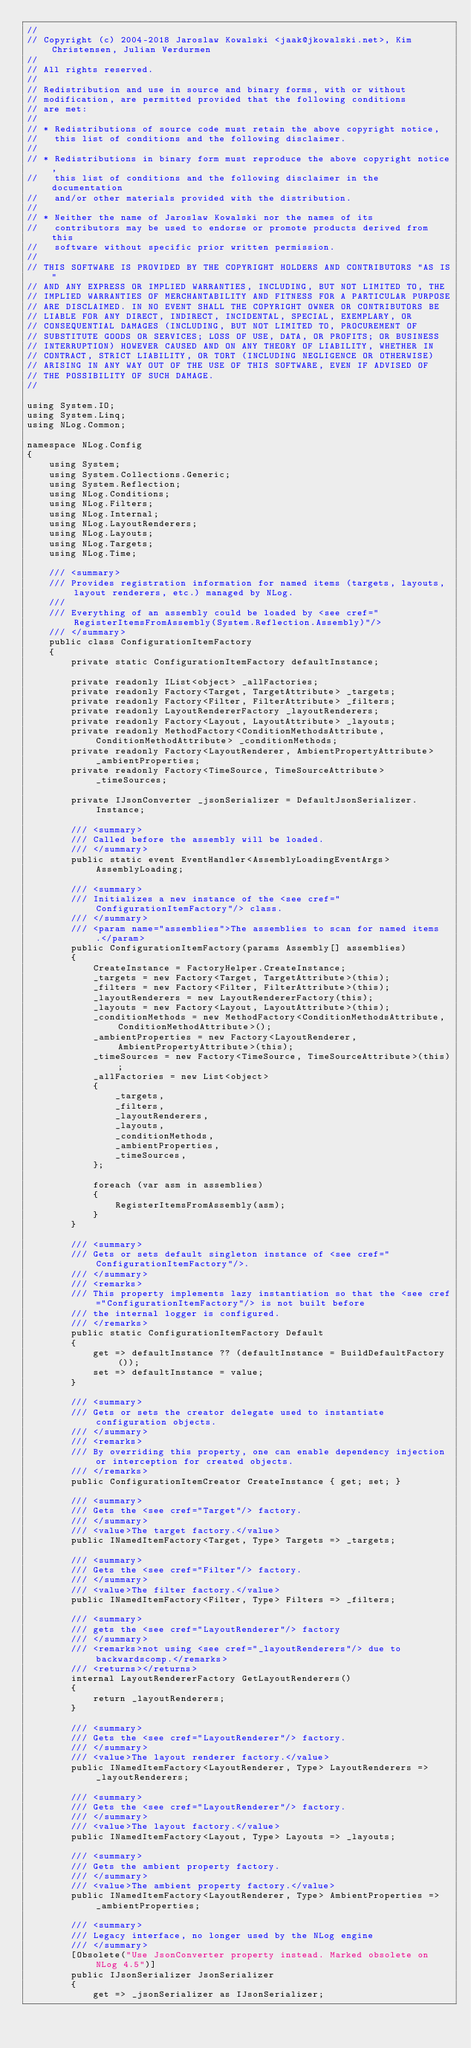Convert code to text. <code><loc_0><loc_0><loc_500><loc_500><_C#_>// 
// Copyright (c) 2004-2018 Jaroslaw Kowalski <jaak@jkowalski.net>, Kim Christensen, Julian Verdurmen
// 
// All rights reserved.
// 
// Redistribution and use in source and binary forms, with or without 
// modification, are permitted provided that the following conditions 
// are met:
// 
// * Redistributions of source code must retain the above copyright notice, 
//   this list of conditions and the following disclaimer. 
// 
// * Redistributions in binary form must reproduce the above copyright notice,
//   this list of conditions and the following disclaimer in the documentation
//   and/or other materials provided with the distribution. 
// 
// * Neither the name of Jaroslaw Kowalski nor the names of its 
//   contributors may be used to endorse or promote products derived from this
//   software without specific prior written permission. 
// 
// THIS SOFTWARE IS PROVIDED BY THE COPYRIGHT HOLDERS AND CONTRIBUTORS "AS IS"
// AND ANY EXPRESS OR IMPLIED WARRANTIES, INCLUDING, BUT NOT LIMITED TO, THE 
// IMPLIED WARRANTIES OF MERCHANTABILITY AND FITNESS FOR A PARTICULAR PURPOSE 
// ARE DISCLAIMED. IN NO EVENT SHALL THE COPYRIGHT OWNER OR CONTRIBUTORS BE 
// LIABLE FOR ANY DIRECT, INDIRECT, INCIDENTAL, SPECIAL, EXEMPLARY, OR 
// CONSEQUENTIAL DAMAGES (INCLUDING, BUT NOT LIMITED TO, PROCUREMENT OF
// SUBSTITUTE GOODS OR SERVICES; LOSS OF USE, DATA, OR PROFITS; OR BUSINESS 
// INTERRUPTION) HOWEVER CAUSED AND ON ANY THEORY OF LIABILITY, WHETHER IN 
// CONTRACT, STRICT LIABILITY, OR TORT (INCLUDING NEGLIGENCE OR OTHERWISE) 
// ARISING IN ANY WAY OUT OF THE USE OF THIS SOFTWARE, EVEN IF ADVISED OF 
// THE POSSIBILITY OF SUCH DAMAGE.
// 

using System.IO;
using System.Linq;
using NLog.Common;

namespace NLog.Config
{
    using System;
    using System.Collections.Generic;
    using System.Reflection;
    using NLog.Conditions;
    using NLog.Filters;
    using NLog.Internal;
    using NLog.LayoutRenderers;
    using NLog.Layouts;
    using NLog.Targets;
    using NLog.Time;

    /// <summary>
    /// Provides registration information for named items (targets, layouts, layout renderers, etc.) managed by NLog.
    /// 
    /// Everything of an assembly could be loaded by <see cref="RegisterItemsFromAssembly(System.Reflection.Assembly)"/>
    /// </summary>
    public class ConfigurationItemFactory
    {
        private static ConfigurationItemFactory defaultInstance;

        private readonly IList<object> _allFactories;
        private readonly Factory<Target, TargetAttribute> _targets;
        private readonly Factory<Filter, FilterAttribute> _filters;
        private readonly LayoutRendererFactory _layoutRenderers;
        private readonly Factory<Layout, LayoutAttribute> _layouts;
        private readonly MethodFactory<ConditionMethodsAttribute, ConditionMethodAttribute> _conditionMethods;
        private readonly Factory<LayoutRenderer, AmbientPropertyAttribute> _ambientProperties;
        private readonly Factory<TimeSource, TimeSourceAttribute> _timeSources;

        private IJsonConverter _jsonSerializer = DefaultJsonSerializer.Instance;

        /// <summary>
        /// Called before the assembly will be loaded.
        /// </summary>
        public static event EventHandler<AssemblyLoadingEventArgs> AssemblyLoading;

        /// <summary>
        /// Initializes a new instance of the <see cref="ConfigurationItemFactory"/> class.
        /// </summary>
        /// <param name="assemblies">The assemblies to scan for named items.</param>
        public ConfigurationItemFactory(params Assembly[] assemblies)
        {
            CreateInstance = FactoryHelper.CreateInstance;
            _targets = new Factory<Target, TargetAttribute>(this);
            _filters = new Factory<Filter, FilterAttribute>(this);
            _layoutRenderers = new LayoutRendererFactory(this);
            _layouts = new Factory<Layout, LayoutAttribute>(this);
            _conditionMethods = new MethodFactory<ConditionMethodsAttribute, ConditionMethodAttribute>();
            _ambientProperties = new Factory<LayoutRenderer, AmbientPropertyAttribute>(this);
            _timeSources = new Factory<TimeSource, TimeSourceAttribute>(this);
            _allFactories = new List<object>
            {
                _targets,
                _filters,
                _layoutRenderers,
                _layouts,
                _conditionMethods,
                _ambientProperties,
                _timeSources,
            };

            foreach (var asm in assemblies)
            {
                RegisterItemsFromAssembly(asm);
            }
        }

        /// <summary>
        /// Gets or sets default singleton instance of <see cref="ConfigurationItemFactory"/>.
        /// </summary>
        /// <remarks>
        /// This property implements lazy instantiation so that the <see cref="ConfigurationItemFactory"/> is not built before 
        /// the internal logger is configured.
        /// </remarks>
        public static ConfigurationItemFactory Default
        {
            get => defaultInstance ?? (defaultInstance = BuildDefaultFactory());
            set => defaultInstance = value;
        }

        /// <summary>
        /// Gets or sets the creator delegate used to instantiate configuration objects.
        /// </summary>
        /// <remarks>
        /// By overriding this property, one can enable dependency injection or interception for created objects.
        /// </remarks>
        public ConfigurationItemCreator CreateInstance { get; set; }

        /// <summary>
        /// Gets the <see cref="Target"/> factory.
        /// </summary>
        /// <value>The target factory.</value>
        public INamedItemFactory<Target, Type> Targets => _targets;

        /// <summary>
        /// Gets the <see cref="Filter"/> factory.
        /// </summary>
        /// <value>The filter factory.</value>
        public INamedItemFactory<Filter, Type> Filters => _filters;

        /// <summary>
        /// gets the <see cref="LayoutRenderer"/> factory
        /// </summary>
        /// <remarks>not using <see cref="_layoutRenderers"/> due to backwardscomp.</remarks>
        /// <returns></returns>
        internal LayoutRendererFactory GetLayoutRenderers()
        {
            return _layoutRenderers;
        }

        /// <summary>
        /// Gets the <see cref="LayoutRenderer"/> factory.
        /// </summary>
        /// <value>The layout renderer factory.</value>
        public INamedItemFactory<LayoutRenderer, Type> LayoutRenderers => _layoutRenderers;

        /// <summary>
        /// Gets the <see cref="LayoutRenderer"/> factory.
        /// </summary>
        /// <value>The layout factory.</value>
        public INamedItemFactory<Layout, Type> Layouts => _layouts;

        /// <summary>
        /// Gets the ambient property factory.
        /// </summary>
        /// <value>The ambient property factory.</value>
        public INamedItemFactory<LayoutRenderer, Type> AmbientProperties => _ambientProperties;

        /// <summary>
        /// Legacy interface, no longer used by the NLog engine
        /// </summary>
        [Obsolete("Use JsonConverter property instead. Marked obsolete on NLog 4.5")]
        public IJsonSerializer JsonSerializer
        {
            get => _jsonSerializer as IJsonSerializer;</code> 